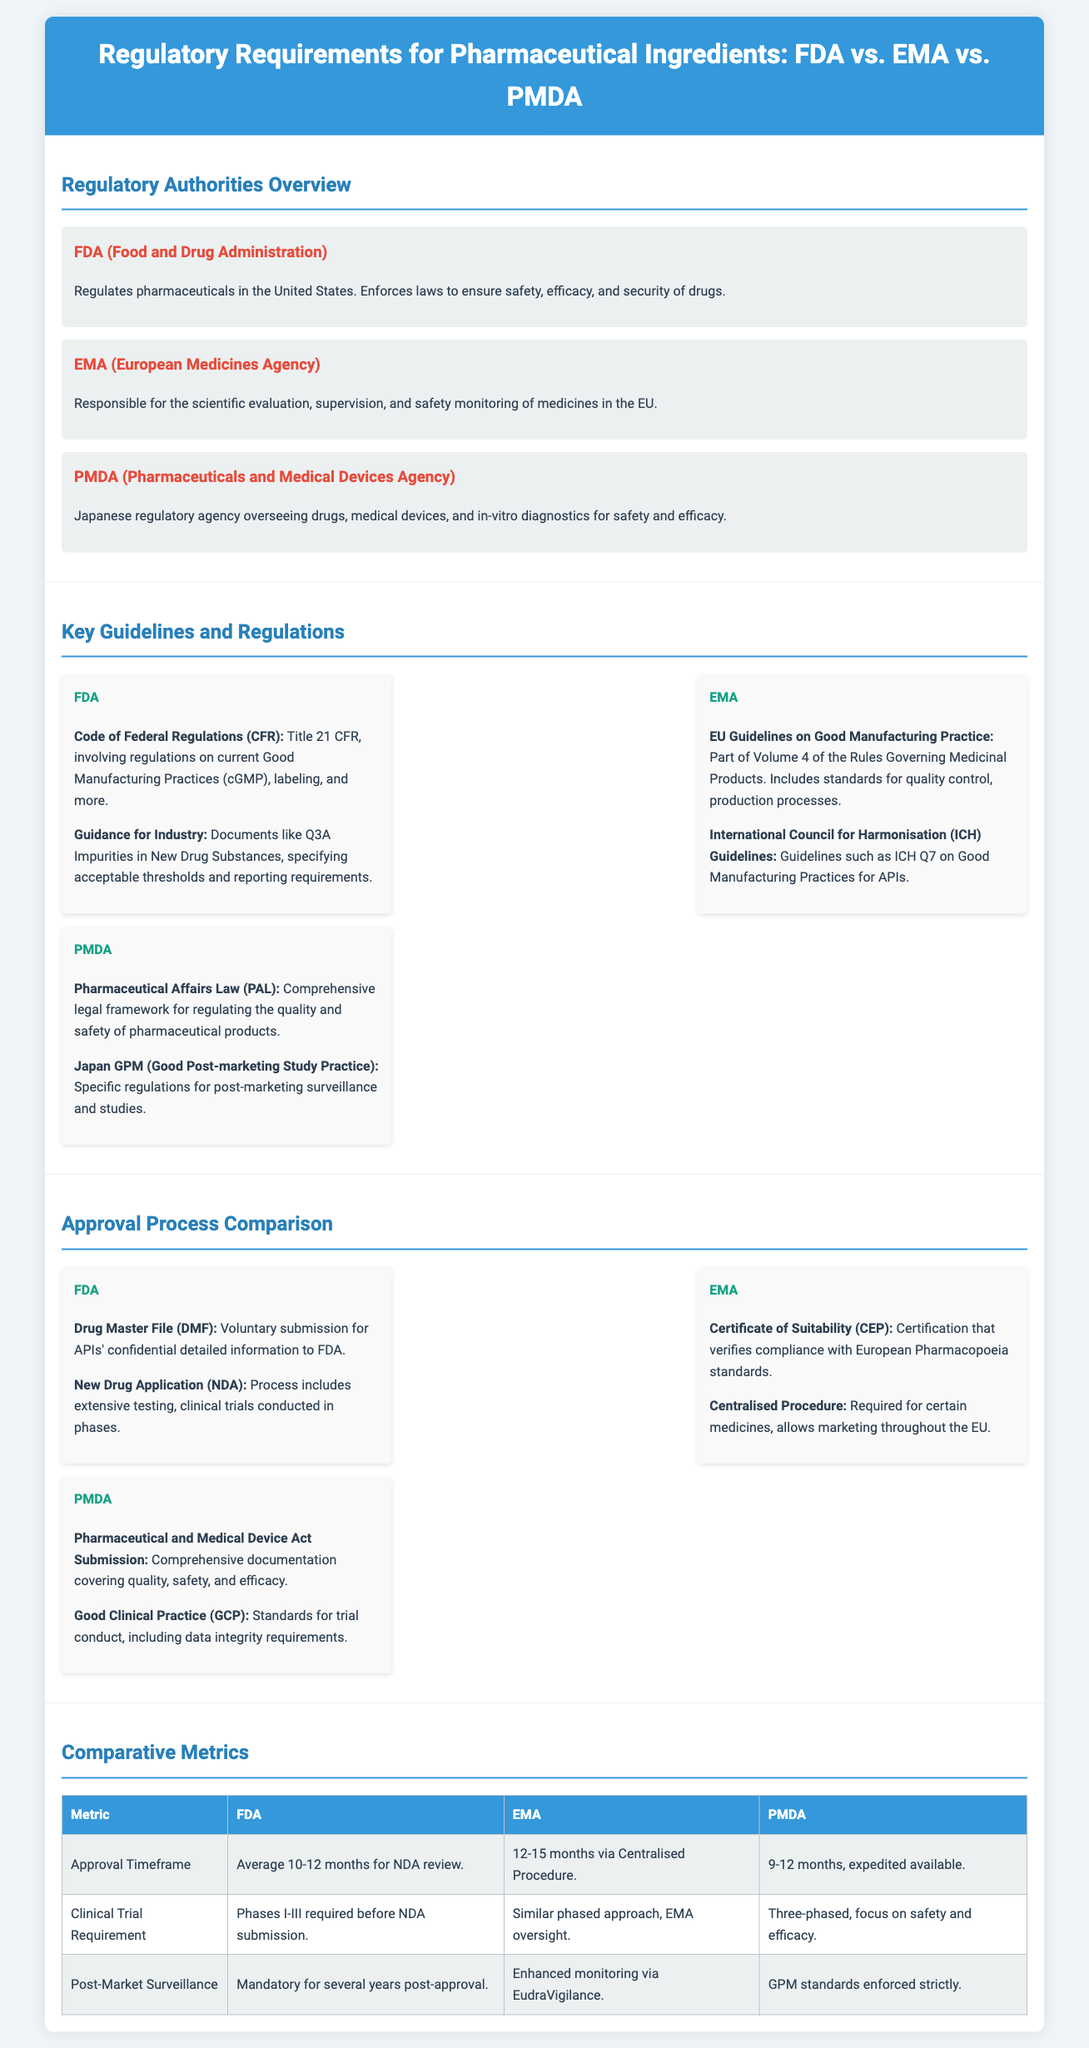what is the regulatory authority for pharmaceuticals in the United States? The document specifies that the regulatory authority is the FDA (Food and Drug Administration).
Answer: FDA how long does the FDA review take on average for an NDA? The average timeframe for an NDA review by the FDA is mentioned as 10-12 months.
Answer: 10-12 months what certification verifies compliance with European Pharmacopoeia standards? The document mentions the Certificate of Suitability (CEP) as the certification for this purpose.
Answer: Certificate of Suitability (CEP) what is a unique guideline mentioned for PMDA? The document notes the Pharmaceutical Affairs Law (PAL) as a unique guideline for the PMDA.
Answer: Pharmaceutical Affairs Law (PAL) which agency is responsible for post-market surveillance in Japan? The PMDA (Pharmaceuticals and Medical Devices Agency) is identified as the responsible agency in Japan for post-market surveillance.
Answer: PMDA what metric highlights the post-market surveillance requirement specified for FDA? The document states that post-market surveillance is mandatory for several years post-approval.
Answer: Mandatory for several years what are the phases required for clinical trials by the FDA before NDA submission? The FDA requires Phases I-III for clinical trials prior to NDA submission.
Answer: Phases I-III what is the average approval timeframe for PMDA? The average timeframe mentioned for PMDA is 9-12 months, with expedited options available.
Answer: 9-12 months which regulatory authority oversees medicines in the EU? The regulatory authority responsible for overseeing medicines in the EU is the EMA (European Medicines Agency).
Answer: EMA what is the approximate review timeframe for the Centralised Procedure by EMA? The document states the review timeframe for the Centralised Procedure by EMA is 12-15 months.
Answer: 12-15 months 